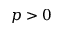Convert formula to latex. <formula><loc_0><loc_0><loc_500><loc_500>p > 0</formula> 